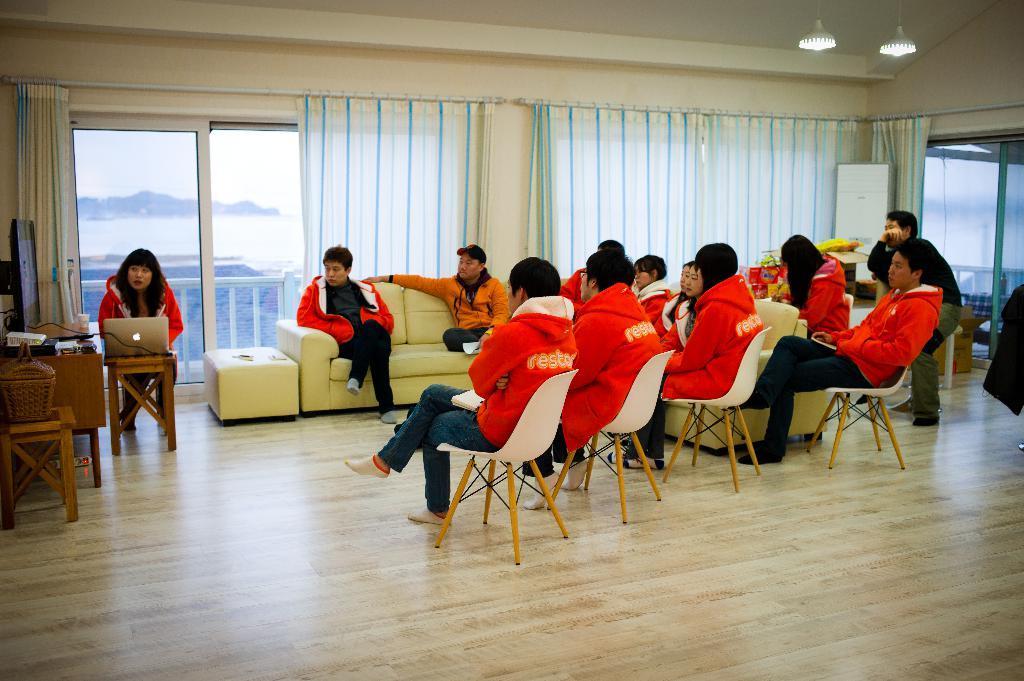Can you describe this image briefly? This Image is clicked in a room. There are sofas and chairs and table. There is a curtain on the backside, there are lights on the top. People are sitting in chair, is sofas. There is a person on the left side who is holding laptop and there is TV on the left side table. 